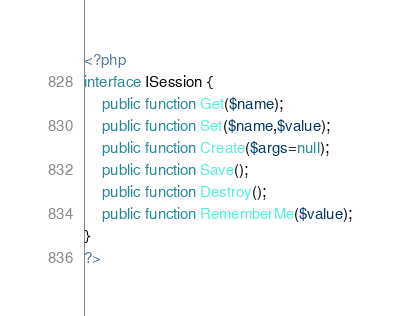Convert code to text. <code><loc_0><loc_0><loc_500><loc_500><_PHP_><?php
interface ISession {
	public function Get($name);
	public function Set($name,$value);
	public function Create($args=null);
	public function Save();
	public function Destroy();
	public function RememberMe($value);
}
?>
</code> 